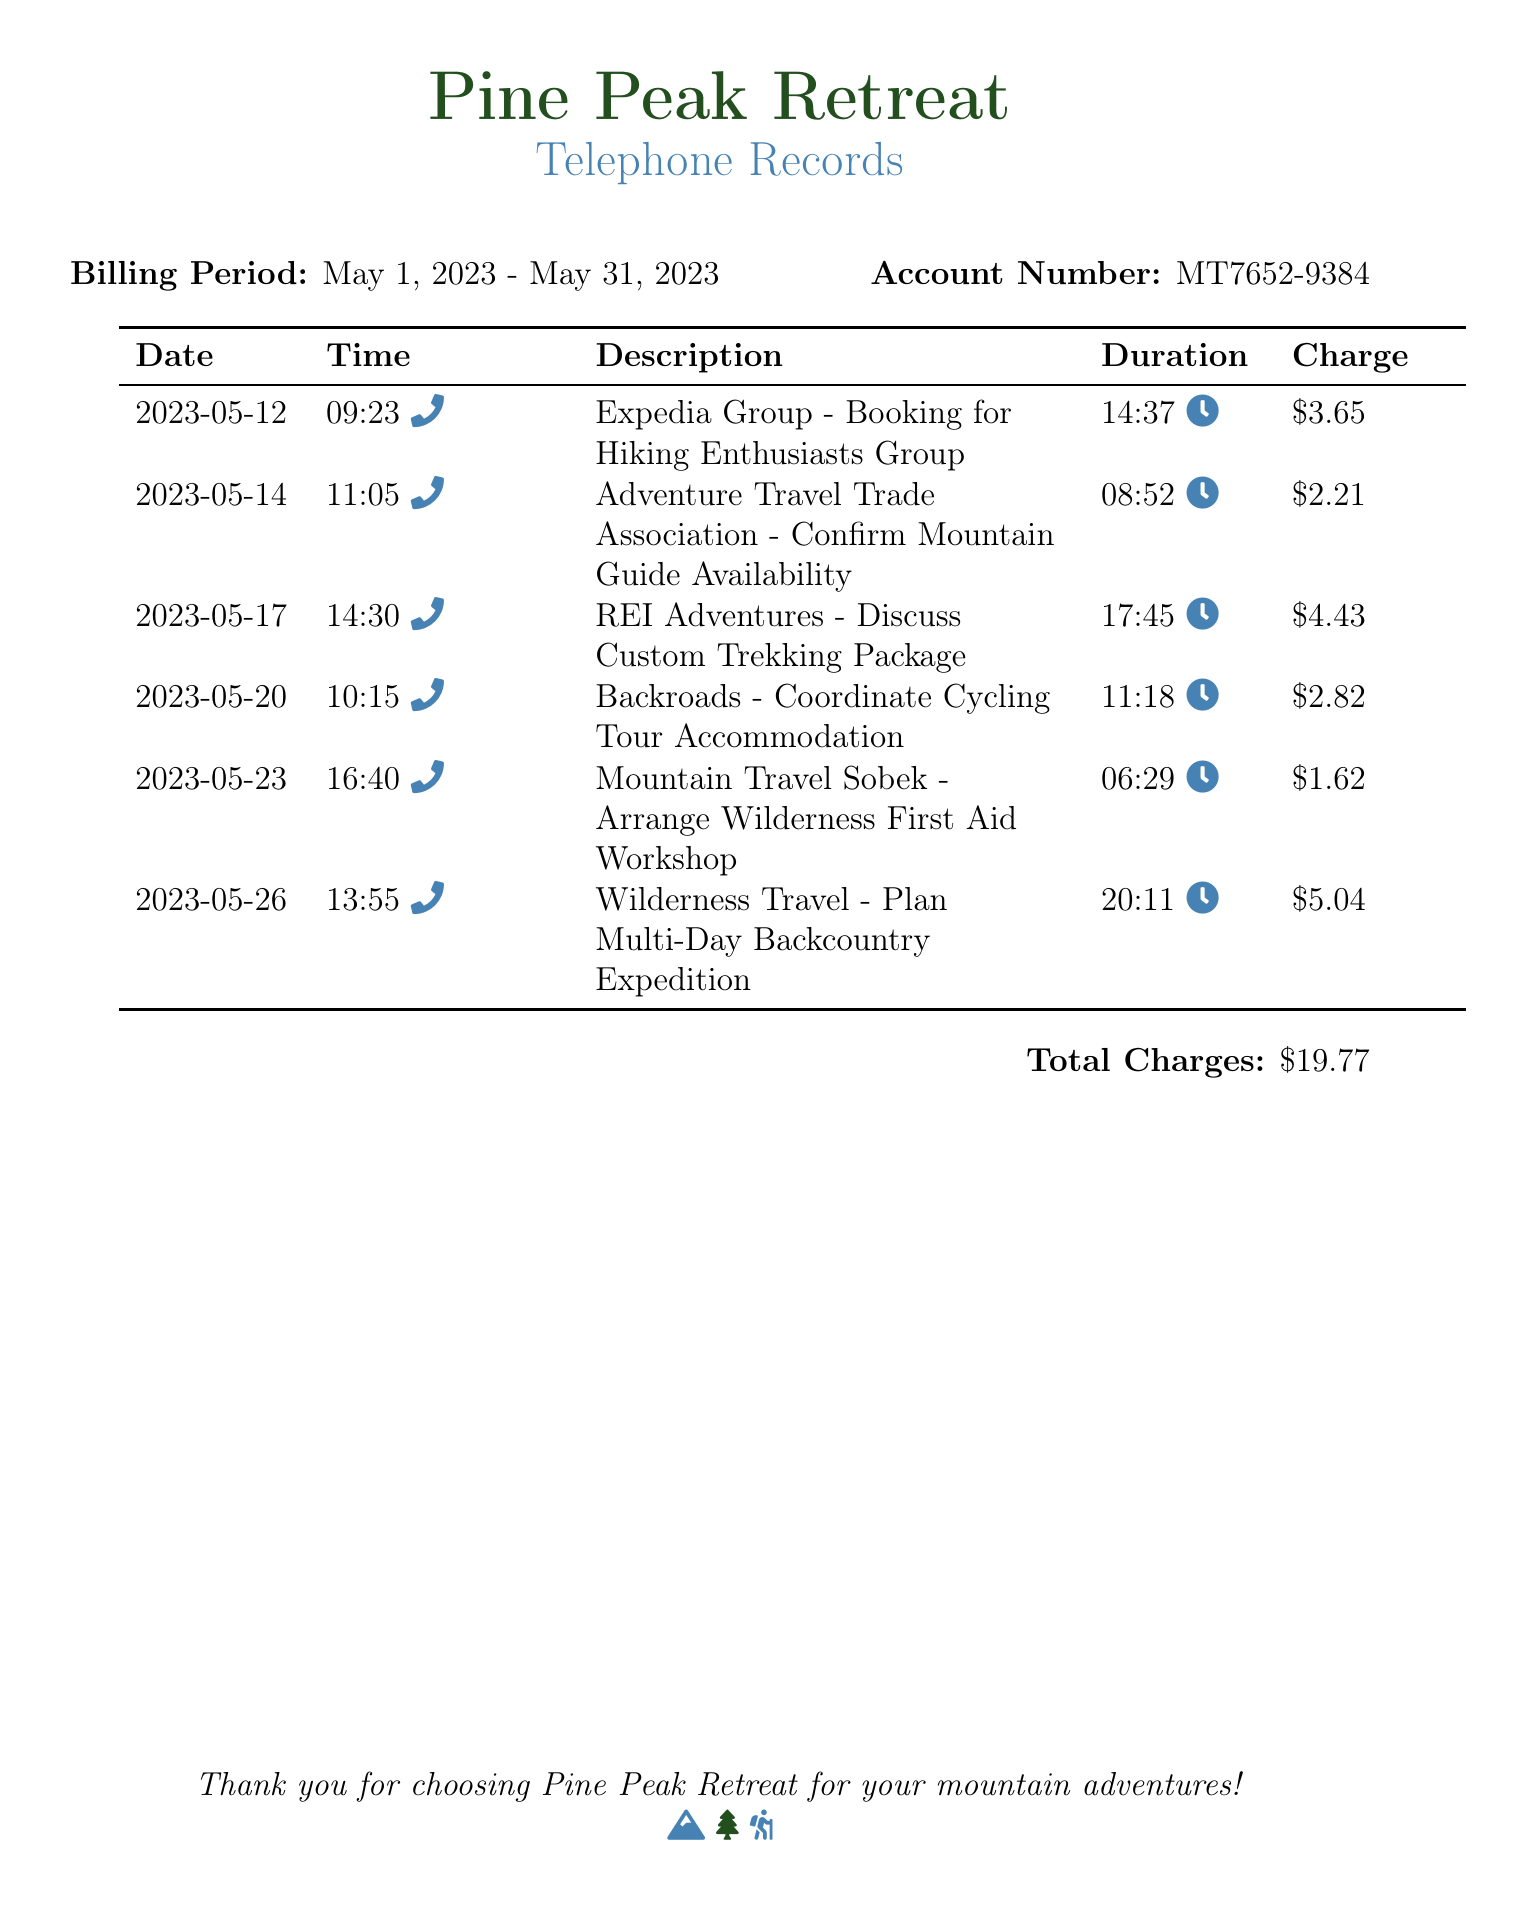What is the total charge for May? The total charge is the sum of all itemized charges for the billing period, which totals $19.77.
Answer: $19.77 How many calls were made in May? The document lists six separate calls made during the billing period.
Answer: 6 What is the duration of the call with REI Adventures? The duration for the call with REI Adventures is listed as 17:45.
Answer: 17:45 Which agency was contacted for arranging a Wilderness First Aid Workshop? The call descriptions include Mountain Travel Sobek for arranging the workshop.
Answer: Mountain Travel Sobek What was the charge for the call related to Adventure Travel Trade Association? The charge for that specific call is shown as $2.21.
Answer: $2.21 On what date was the call made to coordinate Cycling Tour Accommodation? The call to coordinate Cycling Tour Accommodation was made on May 20, 2023.
Answer: May 20, 2023 What was the purpose of the call to Wilderness Travel? The purpose of the call to Wilderness Travel was to plan a multi-day backcountry expedition.
Answer: Plan Multi-Day Backcountry Expedition Which agency was contacted on May 12? The agency contacted on May 12 was Expedia Group.
Answer: Expedia Group What time was the call to discuss a custom trekking package? The call occurred at 14:30.
Answer: 14:30 